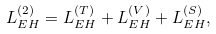Convert formula to latex. <formula><loc_0><loc_0><loc_500><loc_500>L _ { E H } ^ { ( 2 ) } = L _ { E H } ^ { ( T ) } + L _ { E H } ^ { ( V ) } + L _ { E H } ^ { ( S ) } ,</formula> 